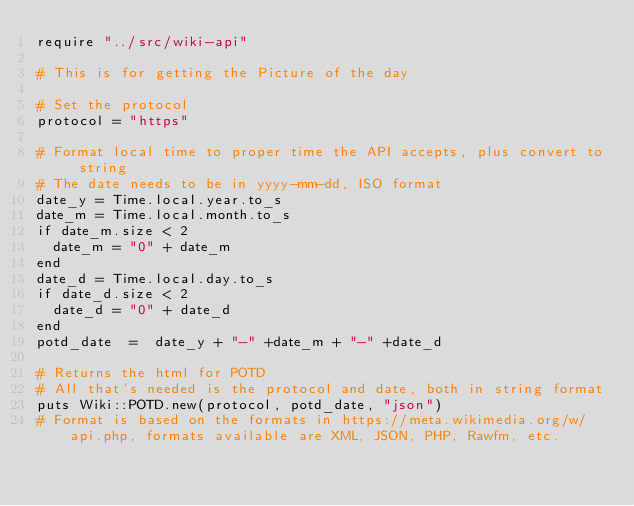<code> <loc_0><loc_0><loc_500><loc_500><_Crystal_>require "../src/wiki-api"

# This is for getting the Picture of the day

# Set the protocol
protocol = "https"

# Format local time to proper time the API accepts, plus convert to string
# The date needs to be in yyyy-mm-dd, ISO format
date_y = Time.local.year.to_s
date_m = Time.local.month.to_s
if date_m.size < 2
  date_m = "0" + date_m
end
date_d = Time.local.day.to_s
if date_d.size < 2
  date_d = "0" + date_d
end
potd_date  =  date_y + "-" +date_m + "-" +date_d

# Returns the html for POTD
# All that's needed is the protocol and date, both in string format
puts Wiki::POTD.new(protocol, potd_date, "json")
# Format is based on the formats in https://meta.wikimedia.org/w/api.php, formats available are XML, JSON, PHP, Rawfm, etc.</code> 